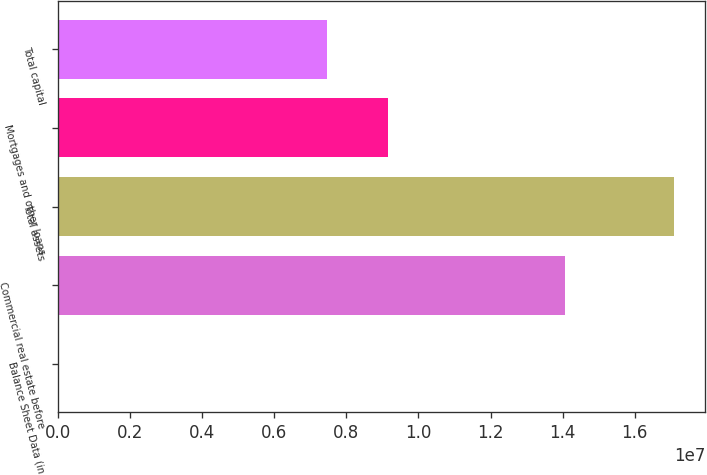Convert chart to OTSL. <chart><loc_0><loc_0><loc_500><loc_500><bar_chart><fcel>Balance Sheet Data (in<fcel>Commercial real estate before<fcel>Total assets<fcel>Mortgages and other loans<fcel>Total capital<nl><fcel>2014<fcel>1.40691e+07<fcel>1.70966e+07<fcel>9.16867e+06<fcel>7.45922e+06<nl></chart> 